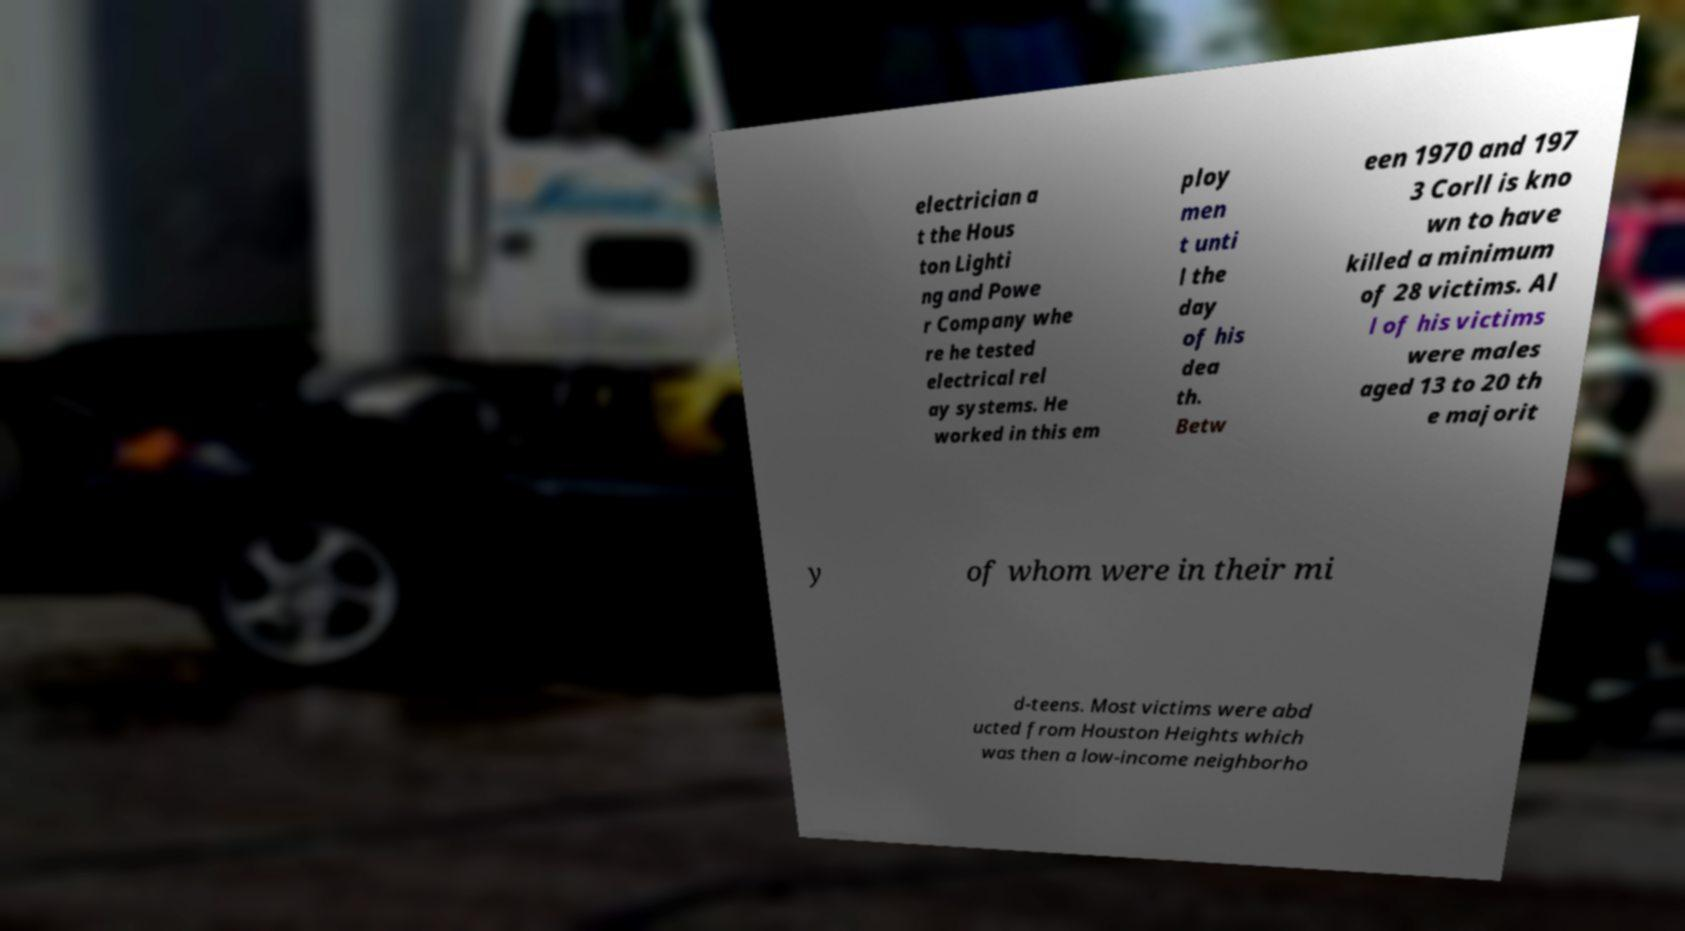Can you accurately transcribe the text from the provided image for me? electrician a t the Hous ton Lighti ng and Powe r Company whe re he tested electrical rel ay systems. He worked in this em ploy men t unti l the day of his dea th. Betw een 1970 and 197 3 Corll is kno wn to have killed a minimum of 28 victims. Al l of his victims were males aged 13 to 20 th e majorit y of whom were in their mi d-teens. Most victims were abd ucted from Houston Heights which was then a low-income neighborho 